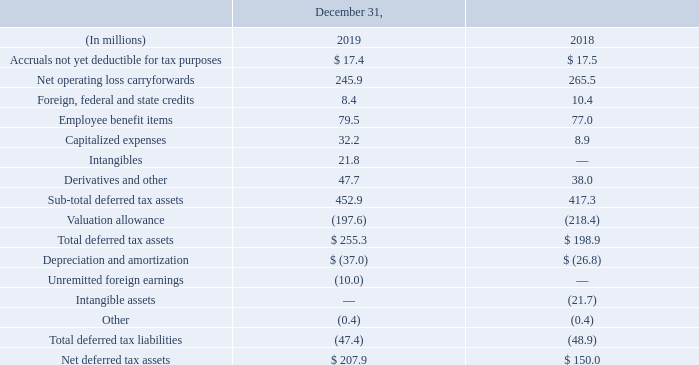Deferred tax assets (liabilities) consist of the following:
A valuation allowance has been provided based on the uncertainty of utilizing the tax benefits, mainly related to the following deferred tax assets: • $183.4 million of foreign items, primarily net operating losses; and • $7.7 million of state tax credits.
For the year ended December 31, 2019, the valuation allowance decreased by $20.8 million. This is primarily driven by our Reinvent SEE initiatives and decreases in foreign tax rates.
As of December 31, 2019, we have foreign net operating loss carryforwards of $899.4 million expiring in years beginning in 2020 with the majority of losses having an unlimited carryover. The state net operating loss carryforwards totaling $569.3 million expire in various amounts over 1 to 19 years.
Of deferred tax assets, how much state tax credits were there? $7.7 million. What does the table show? Deferred tax assets. How much did the valuation allowance decrease by in 2019? $20.8 million. What is the percentage change of Net deferred tax assets from 2018 to 2019?
Answer scale should be: percent. (207.9-150.0)/150.0
Answer: 38.6. What is the percentage of deferred tax assets in foreign items to valuation allowance in 2019?
Answer scale should be: percent. 183.4/197.6
Answer: 92.81. What is the value of Sub-total deferred tax assets as a percentage of Net deferred tax assets for 2019?
Answer scale should be: percent. 452.9/207.9
Answer: 217.85. 